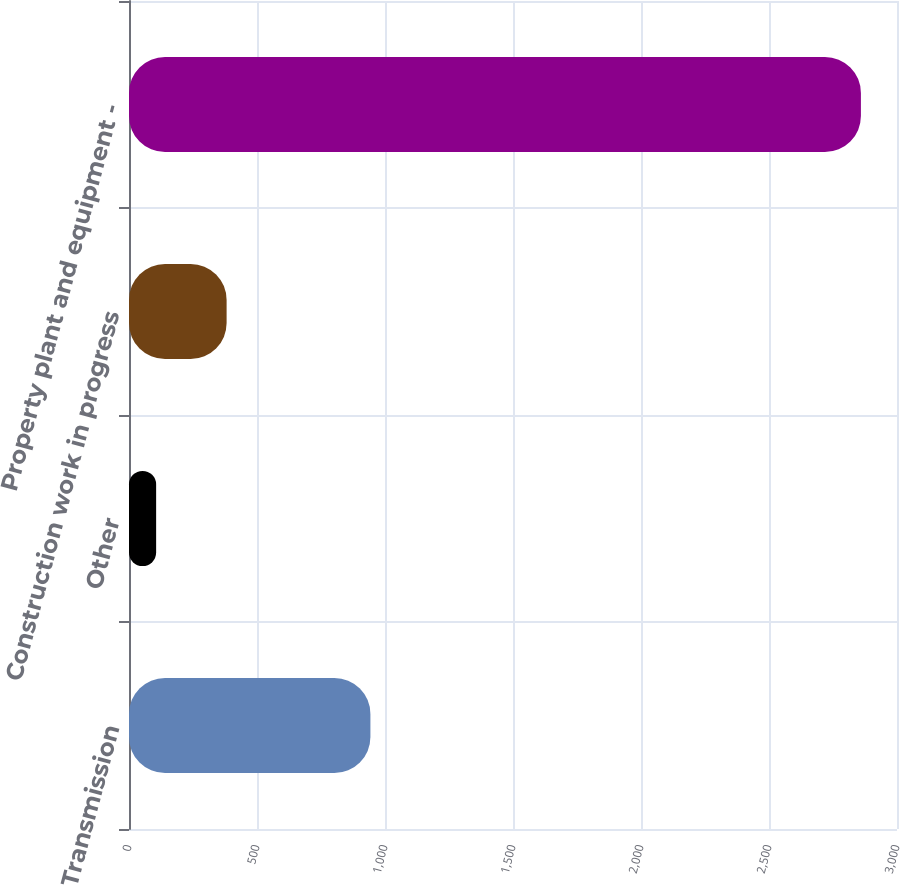<chart> <loc_0><loc_0><loc_500><loc_500><bar_chart><fcel>Transmission<fcel>Other<fcel>Construction work in progress<fcel>Property plant and equipment -<nl><fcel>943<fcel>106<fcel>381.3<fcel>2859<nl></chart> 